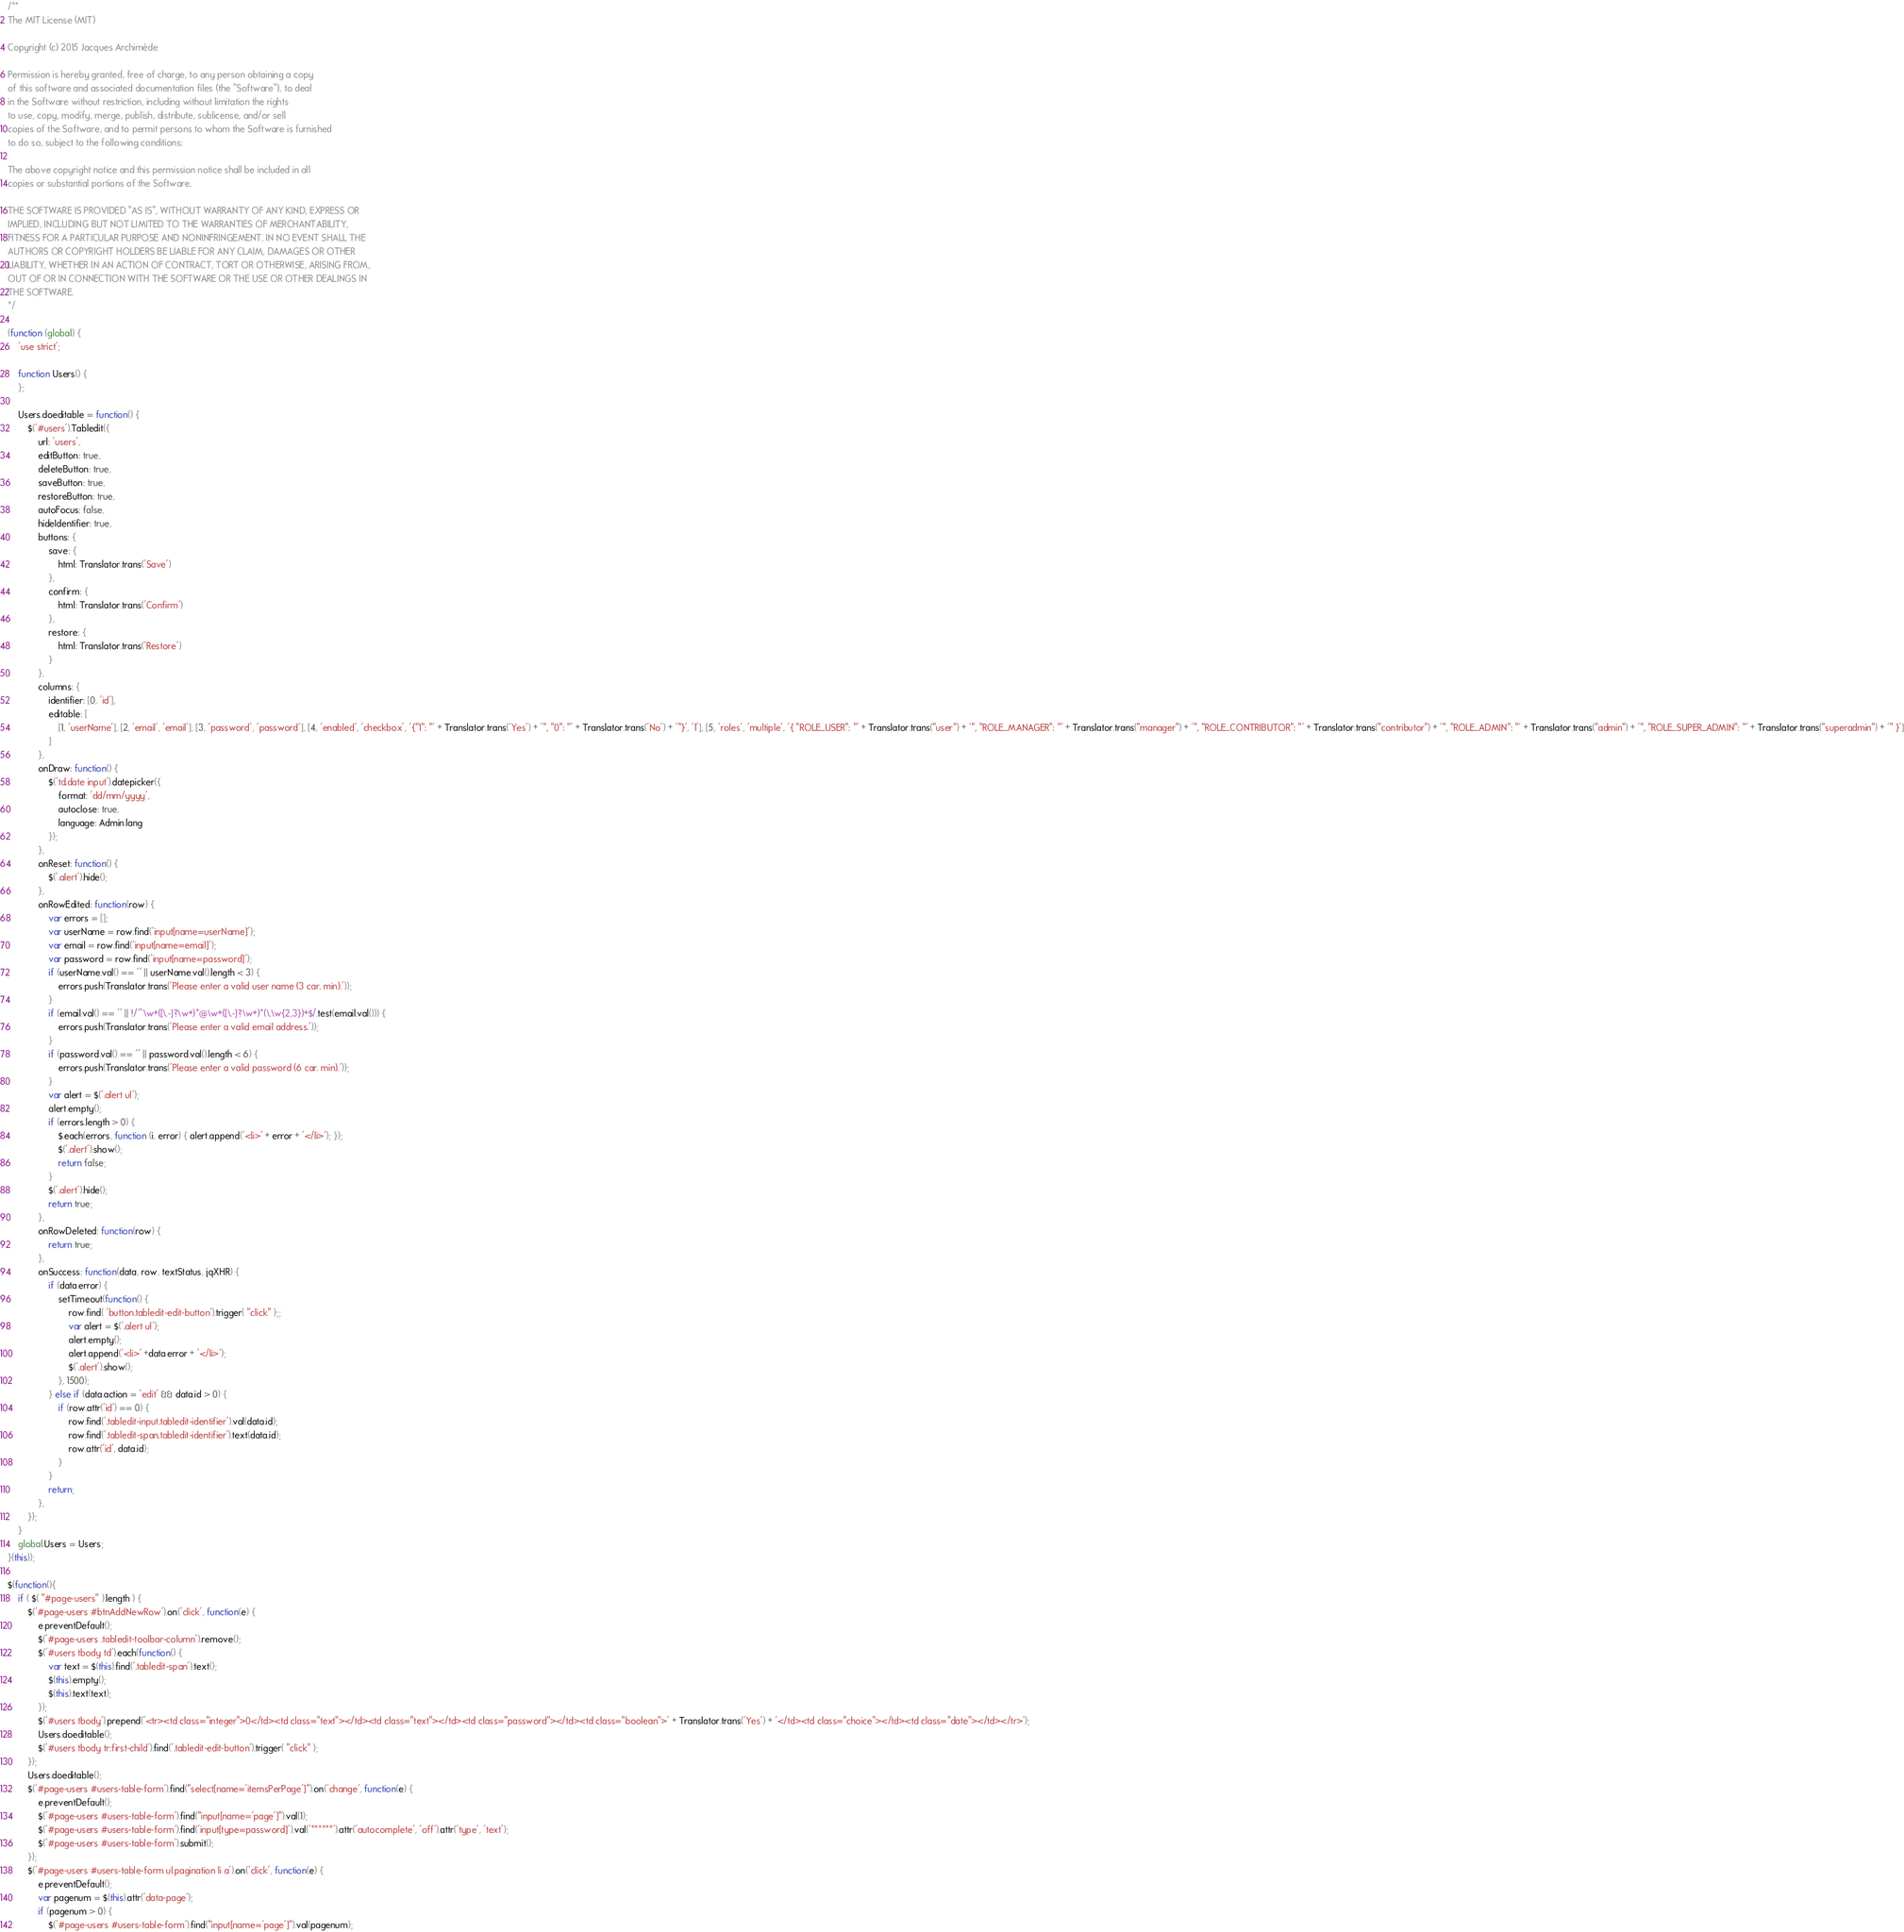Convert code to text. <code><loc_0><loc_0><loc_500><loc_500><_JavaScript_>/**
The MIT License (MIT)

Copyright (c) 2015 Jacques Archimède

Permission is hereby granted, free of charge, to any person obtaining a copy
of this software and associated documentation files (the "Software"), to deal
in the Software without restriction, including without limitation the rights
to use, copy, modify, merge, publish, distribute, sublicense, and/or sell
copies of the Software, and to permit persons to whom the Software is furnished
to do so, subject to the following conditions:

The above copyright notice and this permission notice shall be included in all
copies or substantial portions of the Software.

THE SOFTWARE IS PROVIDED "AS IS", WITHOUT WARRANTY OF ANY KIND, EXPRESS OR
IMPLIED, INCLUDING BUT NOT LIMITED TO THE WARRANTIES OF MERCHANTABILITY,
FITNESS FOR A PARTICULAR PURPOSE AND NONINFRINGEMENT. IN NO EVENT SHALL THE
AUTHORS OR COPYRIGHT HOLDERS BE LIABLE FOR ANY CLAIM, DAMAGES OR OTHER
LIABILITY, WHETHER IN AN ACTION OF CONTRACT, TORT OR OTHERWISE, ARISING FROM,
OUT OF OR IN CONNECTION WITH THE SOFTWARE OR THE USE OR OTHER DEALINGS IN
THE SOFTWARE.
*/

(function (global) {
	'use strict';

	function Users() {
	};

	Users.doeditable = function() {
		$('#users').Tabledit({
			url: 'users',
			editButton: true,
			deleteButton: true,
			saveButton: true,
			restoreButton: true,
			autoFocus: false,
			hideIdentifier: true,
			buttons: {
				save: {
					html: Translator.trans('Save')
				},
				confirm: {
					html: Translator.trans('Confirm')
				},
				restore: {
					html: Translator.trans('Restore')
				}
			},
			columns: {
				identifier: [0, 'id'],
				editable: [
					[1, 'userName'], [2, 'email', 'email'], [3, 'password', 'password'], [4, 'enabled', 'checkbox', '{"1": "' + Translator.trans('Yes') + '", "0": "' + Translator.trans('No') + '"}', '1'], [5, 'roles', 'multiple', '{ "ROLE_USER": "' + Translator.trans("user") + '", "ROLE_MANAGER": "' + Translator.trans("manager") + '", "ROLE_CONTRIBUTOR": "' + Translator.trans("contributor") + '", "ROLE_ADMIN": "' + Translator.trans("admin") + '", "ROLE_SUPER_ADMIN": "' + Translator.trans("superadmin") + '" }']
				]
			},
			onDraw: function() {
				$('td.date input').datepicker({
					format: 'dd/mm/yyyy',
					autoclose: true,
					language: Admin.lang
				});
			},
			onReset: function() {
				$('.alert').hide();
			},
			onRowEdited: function(row) {
				var errors = [];
				var userName = row.find('input[name=userName]');
				var email = row.find('input[name=email]');
				var password = row.find('input[name=password]');
				if (userName.val() == '' || userName.val().length < 3) {
					errors.push(Translator.trans('Please enter a valid user name (3 car. min).'));
				}
				if (email.val() == '' || !/^\w+([\.-]?\w+)*@\w+([\.-]?\w+)*(\.\w{2,3})+$/.test(email.val())) {
					errors.push(Translator.trans('Please enter a valid email address.'));
				}
				if (password.val() == '' || password.val().length < 6) {
					errors.push(Translator.trans('Please enter a valid password (6 car. min).'));
				}
				var alert = $('.alert ul');
				alert.empty();
				if (errors.length > 0) {
					$.each(errors, function (i, error) { alert.append('<li>' + error + '</li>'); });
					$('.alert').show();
					return false;
				}
				$('.alert').hide();
				return true; 
			},
			onRowDeleted: function(row) {
				return true; 
			},
			onSuccess: function(data, row, textStatus, jqXHR) {
				if (data.error) {
					setTimeout(function() {
						row.find( 'button.tabledit-edit-button').trigger( "click" );;
						var alert = $('.alert ul');
						alert.empty();
						alert.append('<li>' +data.error + '</li>');
						$('.alert').show();
					}, 1500);
				} else if (data.action = 'edit' && data.id > 0) {
					if (row.attr('id') == 0) {
						row.find('.tabledit-input.tabledit-identifier').val(data.id);
						row.find('.tabledit-span.tabledit-identifier').text(data.id);
						row.attr('id', data.id);
					}
				}
				return; 
			},
		});
	}
	global.Users = Users;
}(this));

$(function(){
	if ( $( "#page-users" ).length ) {
		$('#page-users #btnAddNewRow').on('click', function(e) {
			e.preventDefault();
			$('#page-users .tabledit-toolbar-column').remove();
			$('#users tbody td').each(function() {
				var text = $(this).find('.tabledit-span').text();
				$(this).empty();
				$(this).text(text);
			});
			$('#users tbody').prepend('<tr><td class="integer">0</td><td class="text"></td><td class="text"></td><td class="password"></td><td class="boolean">' + Translator.trans('Yes') + '</td><td class="choice"></td><td class="date"></td></tr>');
			Users.doeditable();
			$('#users tbody tr:first-child').find('.tabledit-edit-button').trigger( "click" );
		});
		Users.doeditable();
		$('#page-users #users-table-form').find("select[name='itemsPerPage']").on('change', function(e) {
			e.preventDefault();
			$('#page-users #users-table-form').find("input[name='page']").val(1);
			$('#page-users #users-table-form').find('input[type=password]').val('******').attr('autocomplete', 'off').attr('type', 'text');
			$('#page-users #users-table-form').submit();
		});
		$('#page-users #users-table-form ul.pagination li a').on('click', function(e) {
			e.preventDefault();
			var pagenum = $(this).attr('data-page');
			if (pagenum > 0) {
				$('#page-users #users-table-form').find("input[name='page']").val(pagenum);</code> 